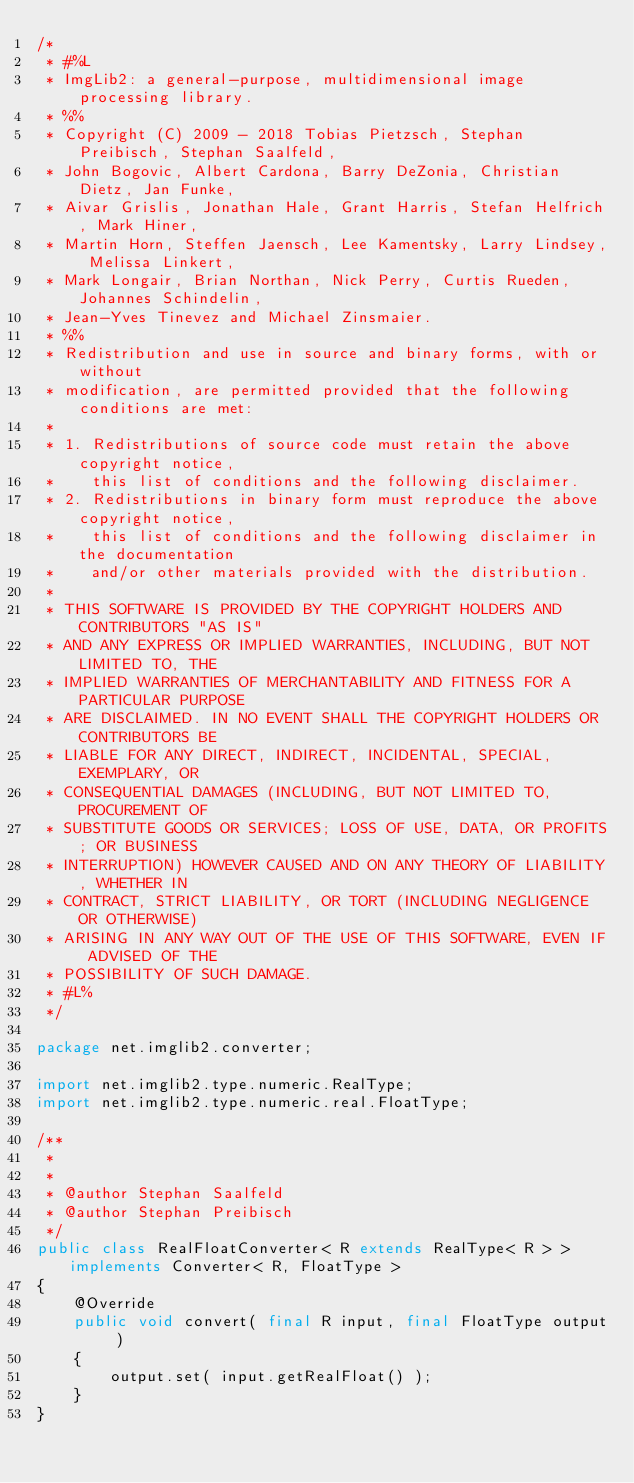<code> <loc_0><loc_0><loc_500><loc_500><_Java_>/*
 * #%L
 * ImgLib2: a general-purpose, multidimensional image processing library.
 * %%
 * Copyright (C) 2009 - 2018 Tobias Pietzsch, Stephan Preibisch, Stephan Saalfeld,
 * John Bogovic, Albert Cardona, Barry DeZonia, Christian Dietz, Jan Funke,
 * Aivar Grislis, Jonathan Hale, Grant Harris, Stefan Helfrich, Mark Hiner,
 * Martin Horn, Steffen Jaensch, Lee Kamentsky, Larry Lindsey, Melissa Linkert,
 * Mark Longair, Brian Northan, Nick Perry, Curtis Rueden, Johannes Schindelin,
 * Jean-Yves Tinevez and Michael Zinsmaier.
 * %%
 * Redistribution and use in source and binary forms, with or without
 * modification, are permitted provided that the following conditions are met:
 * 
 * 1. Redistributions of source code must retain the above copyright notice,
 *    this list of conditions and the following disclaimer.
 * 2. Redistributions in binary form must reproduce the above copyright notice,
 *    this list of conditions and the following disclaimer in the documentation
 *    and/or other materials provided with the distribution.
 * 
 * THIS SOFTWARE IS PROVIDED BY THE COPYRIGHT HOLDERS AND CONTRIBUTORS "AS IS"
 * AND ANY EXPRESS OR IMPLIED WARRANTIES, INCLUDING, BUT NOT LIMITED TO, THE
 * IMPLIED WARRANTIES OF MERCHANTABILITY AND FITNESS FOR A PARTICULAR PURPOSE
 * ARE DISCLAIMED. IN NO EVENT SHALL THE COPYRIGHT HOLDERS OR CONTRIBUTORS BE
 * LIABLE FOR ANY DIRECT, INDIRECT, INCIDENTAL, SPECIAL, EXEMPLARY, OR
 * CONSEQUENTIAL DAMAGES (INCLUDING, BUT NOT LIMITED TO, PROCUREMENT OF
 * SUBSTITUTE GOODS OR SERVICES; LOSS OF USE, DATA, OR PROFITS; OR BUSINESS
 * INTERRUPTION) HOWEVER CAUSED AND ON ANY THEORY OF LIABILITY, WHETHER IN
 * CONTRACT, STRICT LIABILITY, OR TORT (INCLUDING NEGLIGENCE OR OTHERWISE)
 * ARISING IN ANY WAY OUT OF THE USE OF THIS SOFTWARE, EVEN IF ADVISED OF THE
 * POSSIBILITY OF SUCH DAMAGE.
 * #L%
 */

package net.imglib2.converter;

import net.imglib2.type.numeric.RealType;
import net.imglib2.type.numeric.real.FloatType;

/**
 * 
 * 
 * @author Stephan Saalfeld
 * @author Stephan Preibisch
 */
public class RealFloatConverter< R extends RealType< R > > implements Converter< R, FloatType >
{
	@Override
	public void convert( final R input, final FloatType output )
	{
		output.set( input.getRealFloat() );
	}
}
</code> 